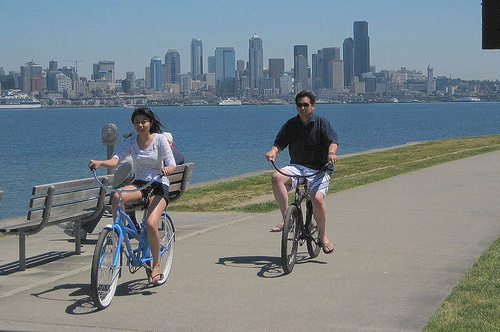Describe the objects in this image and their specific colors. I can see people in darkgray, black, and gray tones, bicycle in darkgray, gray, black, and blue tones, people in darkgray, gray, black, and tan tones, bench in darkgray, gray, and black tones, and bicycle in darkgray, black, and gray tones in this image. 